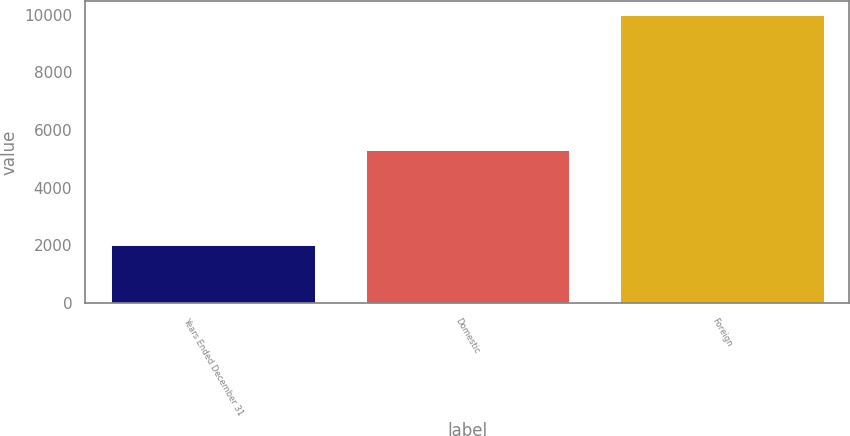Convert chart to OTSL. <chart><loc_0><loc_0><loc_500><loc_500><bar_chart><fcel>Years Ended December 31<fcel>Domestic<fcel>Foreign<nl><fcel>2009<fcel>5318<fcel>9972<nl></chart> 